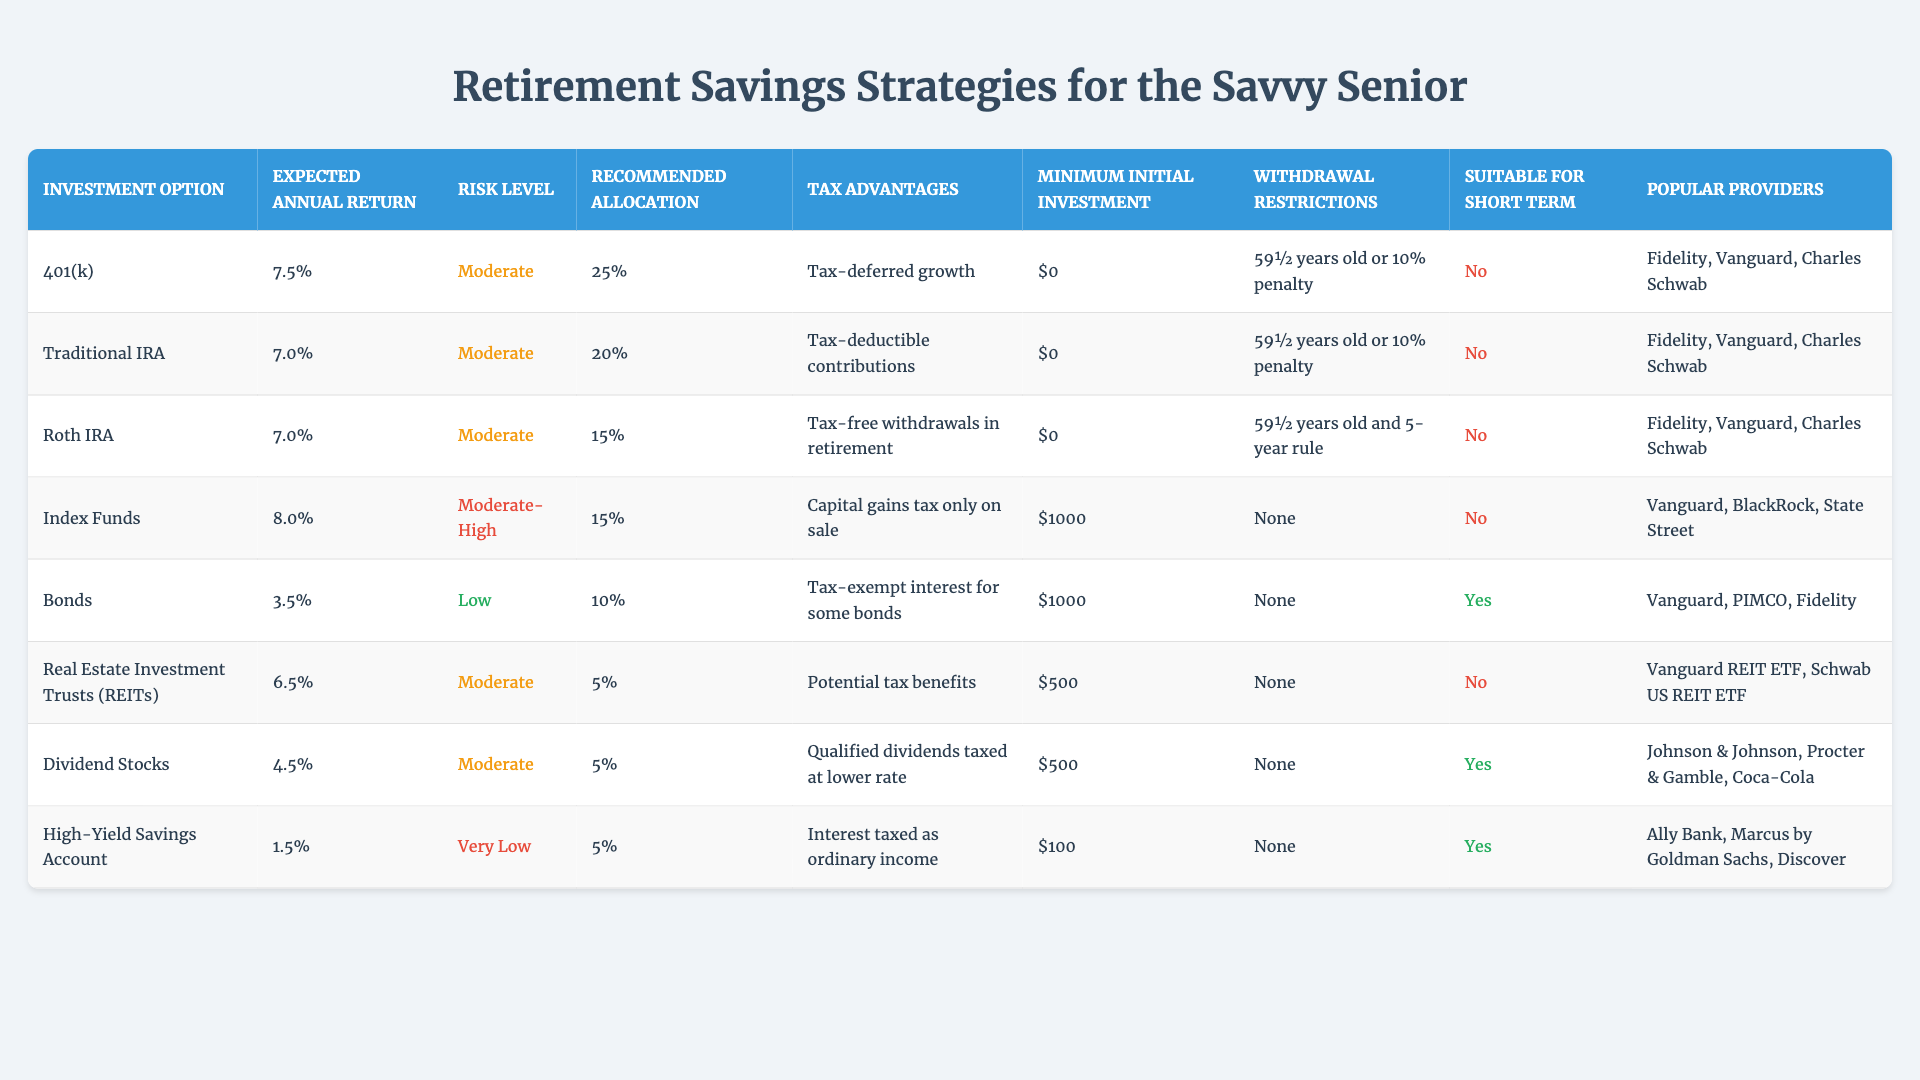What is the expected annual return of Index Funds? The table lists the expected annual return for Index Funds as 8.0%.
Answer: 8.0% Which investment option has the lowest expected annual return? From the table, the High-Yield Savings Account has the lowest expected annual return at 1.5%.
Answer: High-Yield Savings Account Is there any investment option that is suitable for short-term goals? The table indicates that both Bonds and High-Yield Savings Accounts are suitable for short-term goals since they are marked as "Yes."
Answer: Yes What is the recommended allocation percentage for Dividend Stocks? According to the table, the recommended allocation percentage for Dividend Stocks is 5%.
Answer: 5% Which investment options have a moderate risk level and an expected return of 7% or higher? Looking at the table, the 401(k), Traditional IRA, and Dividend Stocks all have a moderate risk level and have expected returns of 7% or higher.
Answer: 401(k), Traditional IRA What is the total recommended allocation percentage for all investment options? By summing up the recommended allocation percentages (25 + 20 + 15 + 15 + 10 + 5 + 5 + 5), we get a total of 100%.
Answer: 100% Can you name an investment option that has no withdrawal restrictions? The table shows that all options except for the 401(k), Traditional IRA, and Roth IRA have no withdrawal restrictions. The answer is any of the following: Index Funds, Bonds, REITs, Dividend Stocks, or High-Yield Savings Account.
Answer: Index Funds How many investment options require a minimum initial investment of $1,000 or more? From the table, we see that Index Funds and Bonds require a minimum initial investment of $1,000. Therefore, there are 2 such investment options.
Answer: 2 What are the tax advantages of a Traditional IRA? The table states that the tax advantage of a Traditional IRA is tax-deductible contributions.
Answer: Tax-deductible contributions Which investment option has the highest expected annual return and moderate risk? The Index Funds have the highest expected annual return (8.0%) but has a moderate-high risk level; hence, it does not meet the criteria. The next option is 401(k), which has a moderate risk level and expected return of 7.5%.
Answer: 401(k) 